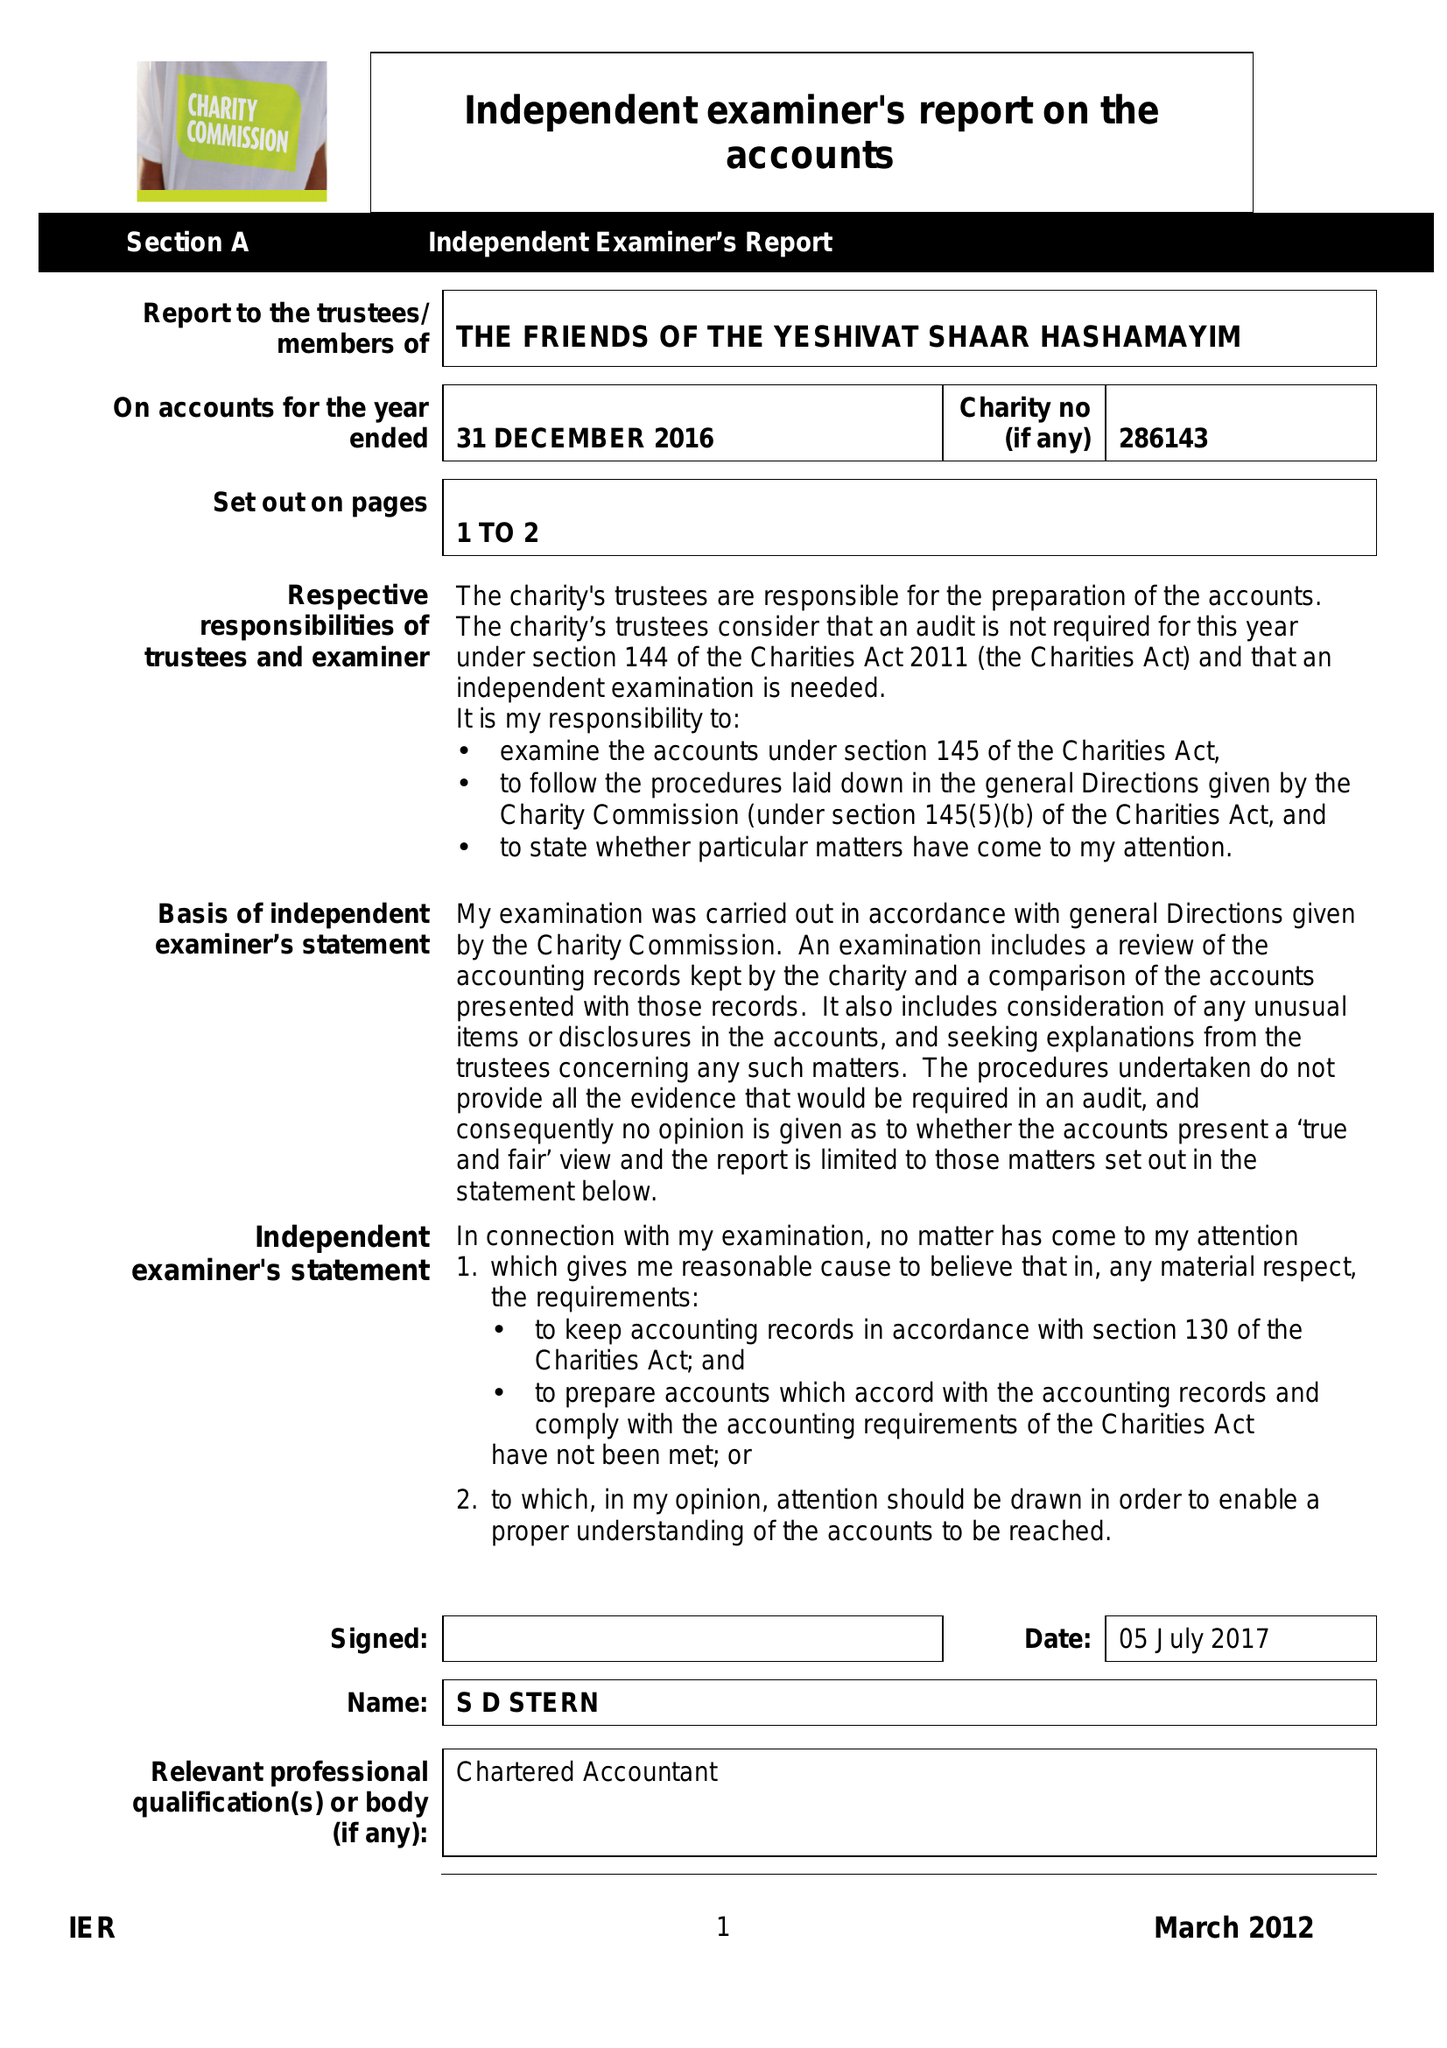What is the value for the charity_name?
Answer the question using a single word or phrase. The Friends Of The Yeshivat Shaar Hashamayim 